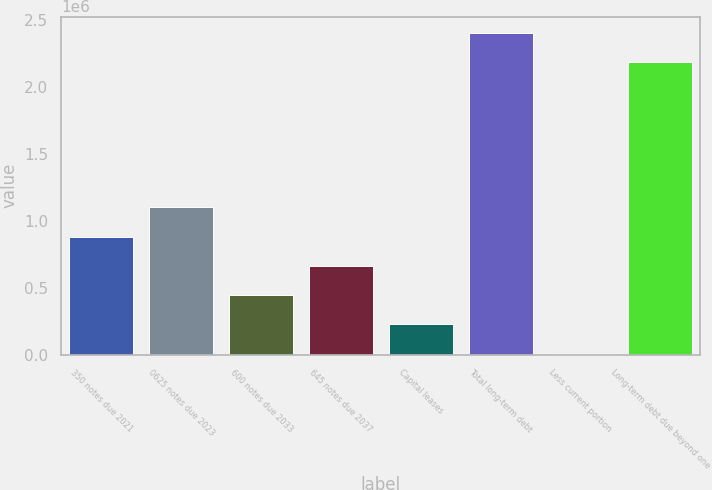Convert chart to OTSL. <chart><loc_0><loc_0><loc_500><loc_500><bar_chart><fcel>350 notes due 2021<fcel>0625 notes due 2023<fcel>600 notes due 2033<fcel>645 notes due 2037<fcel>Capital leases<fcel>Total long-term debt<fcel>Less current portion<fcel>Long-term debt due beyond one<nl><fcel>881281<fcel>1.10006e+06<fcel>443723<fcel>662502<fcel>224944<fcel>2.40657e+06<fcel>6165<fcel>2.18779e+06<nl></chart> 